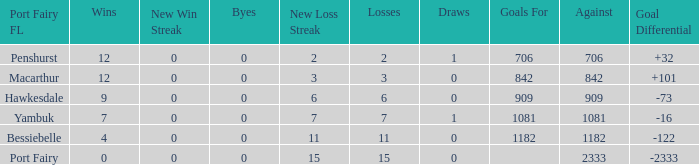How many wins for Port Fairy and against more than 2333? None. 